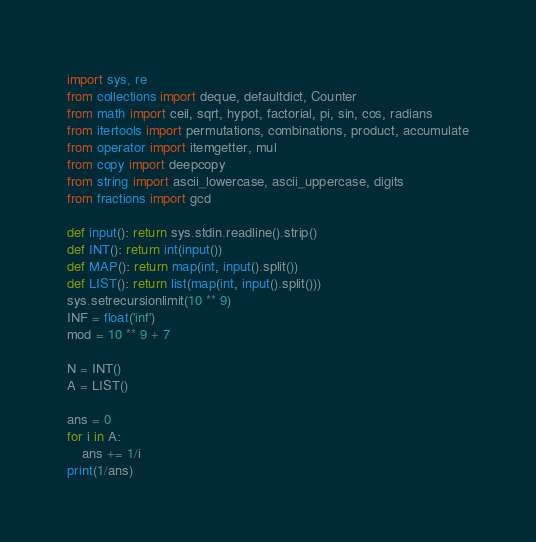<code> <loc_0><loc_0><loc_500><loc_500><_Python_>import sys, re
from collections import deque, defaultdict, Counter
from math import ceil, sqrt, hypot, factorial, pi, sin, cos, radians
from itertools import permutations, combinations, product, accumulate
from operator import itemgetter, mul
from copy import deepcopy
from string import ascii_lowercase, ascii_uppercase, digits
from fractions import gcd

def input(): return sys.stdin.readline().strip()
def INT(): return int(input())
def MAP(): return map(int, input().split())
def LIST(): return list(map(int, input().split()))
sys.setrecursionlimit(10 ** 9)
INF = float('inf')
mod = 10 ** 9 + 7

N = INT()
A = LIST()

ans = 0
for i in A:
	ans += 1/i
print(1/ans)
</code> 